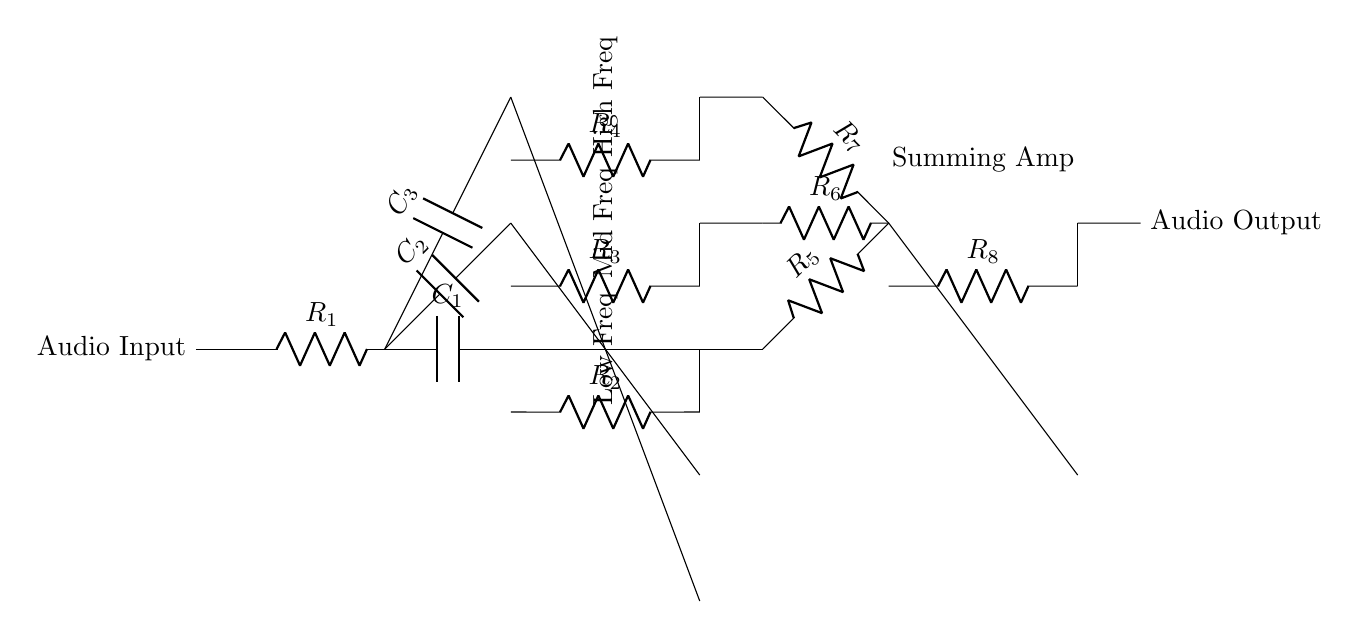What components are included in the circuit? The circuit includes resistors, capacitors, and op-amps. The resistors are labeled R1, R2, R3, R4, R5, R6, R7, and R8; the capacitors are labeled C1, C2, and C3; and there are three op-amps present in the low, mid, and high frequency bands.
Answer: Resistors, capacitors, op-amps What is the function of the op-amps in this circuit? The op-amps serve as amplifiers for each frequency band, allowing for signal conditioning by adjusting the gain of low, mid, and high frequencies separately. This is essential for an audio equalizer to boost or cut specific frequency ranges in an audio signal.
Answer: Amplification How many frequency bands does this equalizer circuit have? The circuit features three distinct frequency bands: low, mid, and high frequencies, each processed by a separate filter stage using capacitors and op-amps.
Answer: Three What is the role of the summing amplifier? The summing amplifier combines the processed output signals from each of the three frequency bands into a single output signal. This is achieved by summing the outputs of the op-amps associated with each band, allowing the user to have a unified audio output after equalization.
Answer: Combination of outputs What type of analog processing does this circuit perform? This circuit performs frequency band filtering and amplification. Each band is filtered by a capacitor to isolate specific frequency ranges, which are then amplified for further processing before being summed into the final audio output.
Answer: Frequency filtering and amplification Which component determines the low frequency response? The capacitor labeled C1 determines the low frequency response. It acts as a high-pass filter in combination with the resistor R2 to shape how the circuit responds to low frequency signals, allowing some frequencies to pass while attenuating others below the cutoff.
Answer: Capacitor C1 What would happen if one of the resistors, for example R3, were to be removed? Removing R3 would disrupt the mid frequency band processing, leading to a lack of control over mid frequencies, resulting in a potential imbalance in the audio signal. The circuit would still function, but mid frequencies would not be adjusted, affecting overall sound quality.
Answer: Loss of mid frequency control 